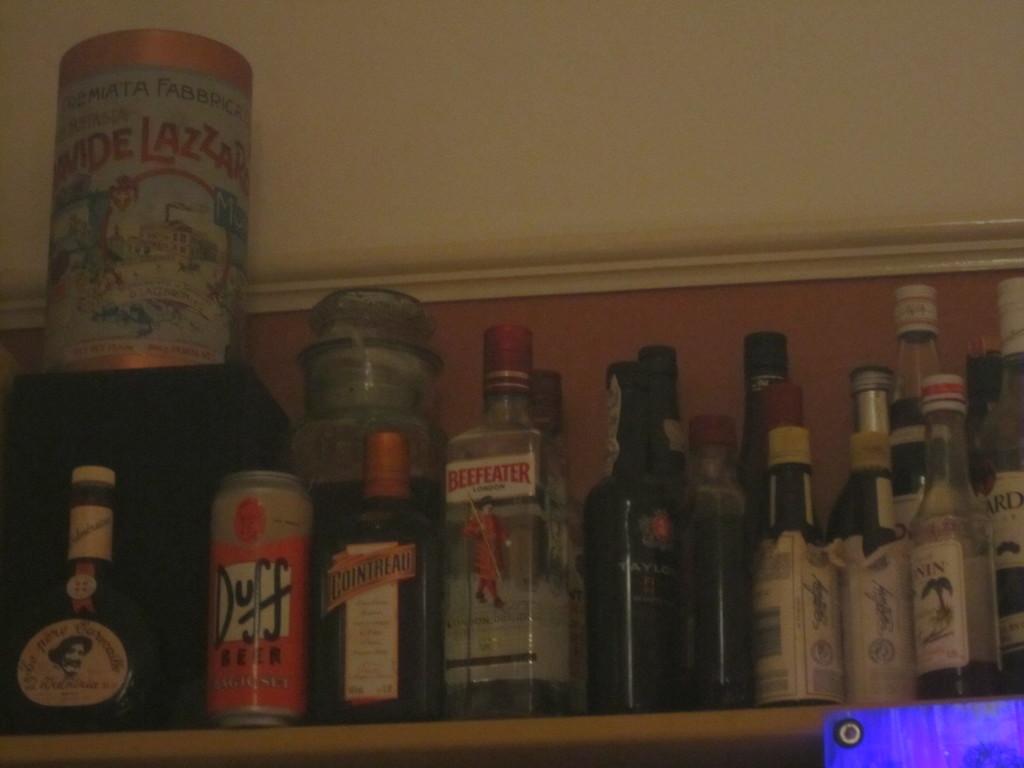What is the orange can?
Offer a very short reply. Duff beer. What is the brand of alcohol in orange letters on the middle bottle?
Offer a terse response. Beefeater. 